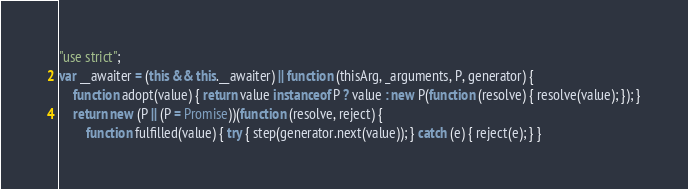<code> <loc_0><loc_0><loc_500><loc_500><_JavaScript_>"use strict";
var __awaiter = (this && this.__awaiter) || function (thisArg, _arguments, P, generator) {
    function adopt(value) { return value instanceof P ? value : new P(function (resolve) { resolve(value); }); }
    return new (P || (P = Promise))(function (resolve, reject) {
        function fulfilled(value) { try { step(generator.next(value)); } catch (e) { reject(e); } }</code> 